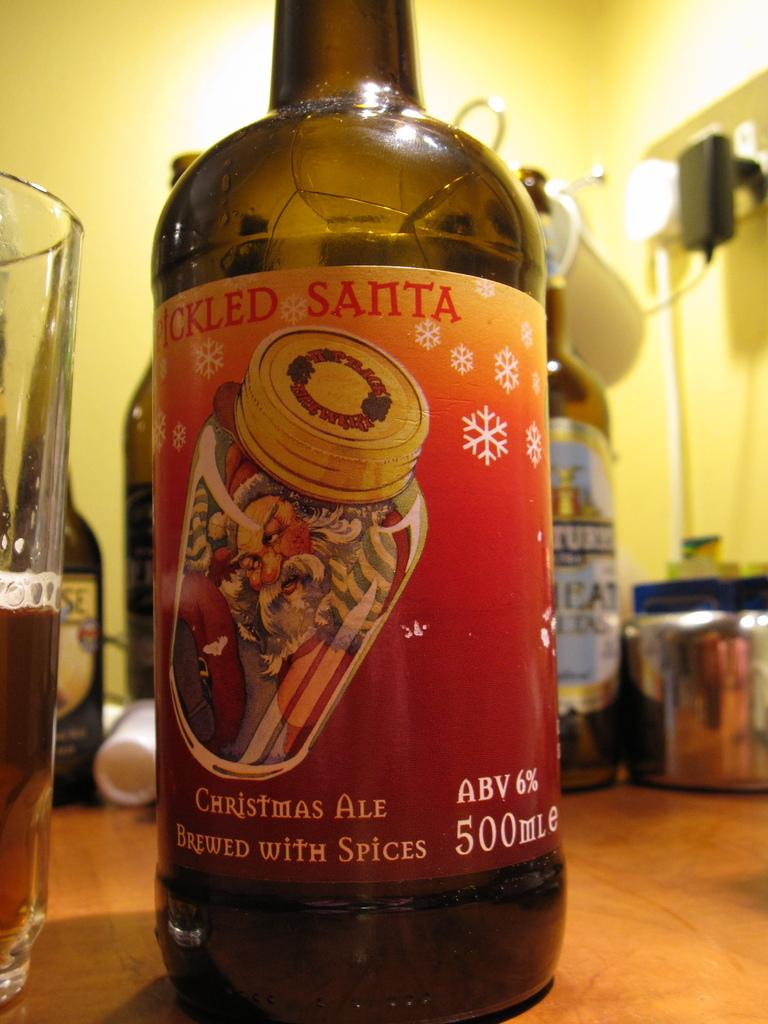<image>
Write a terse but informative summary of the picture. The christmas drink shown is called pickled santa. 